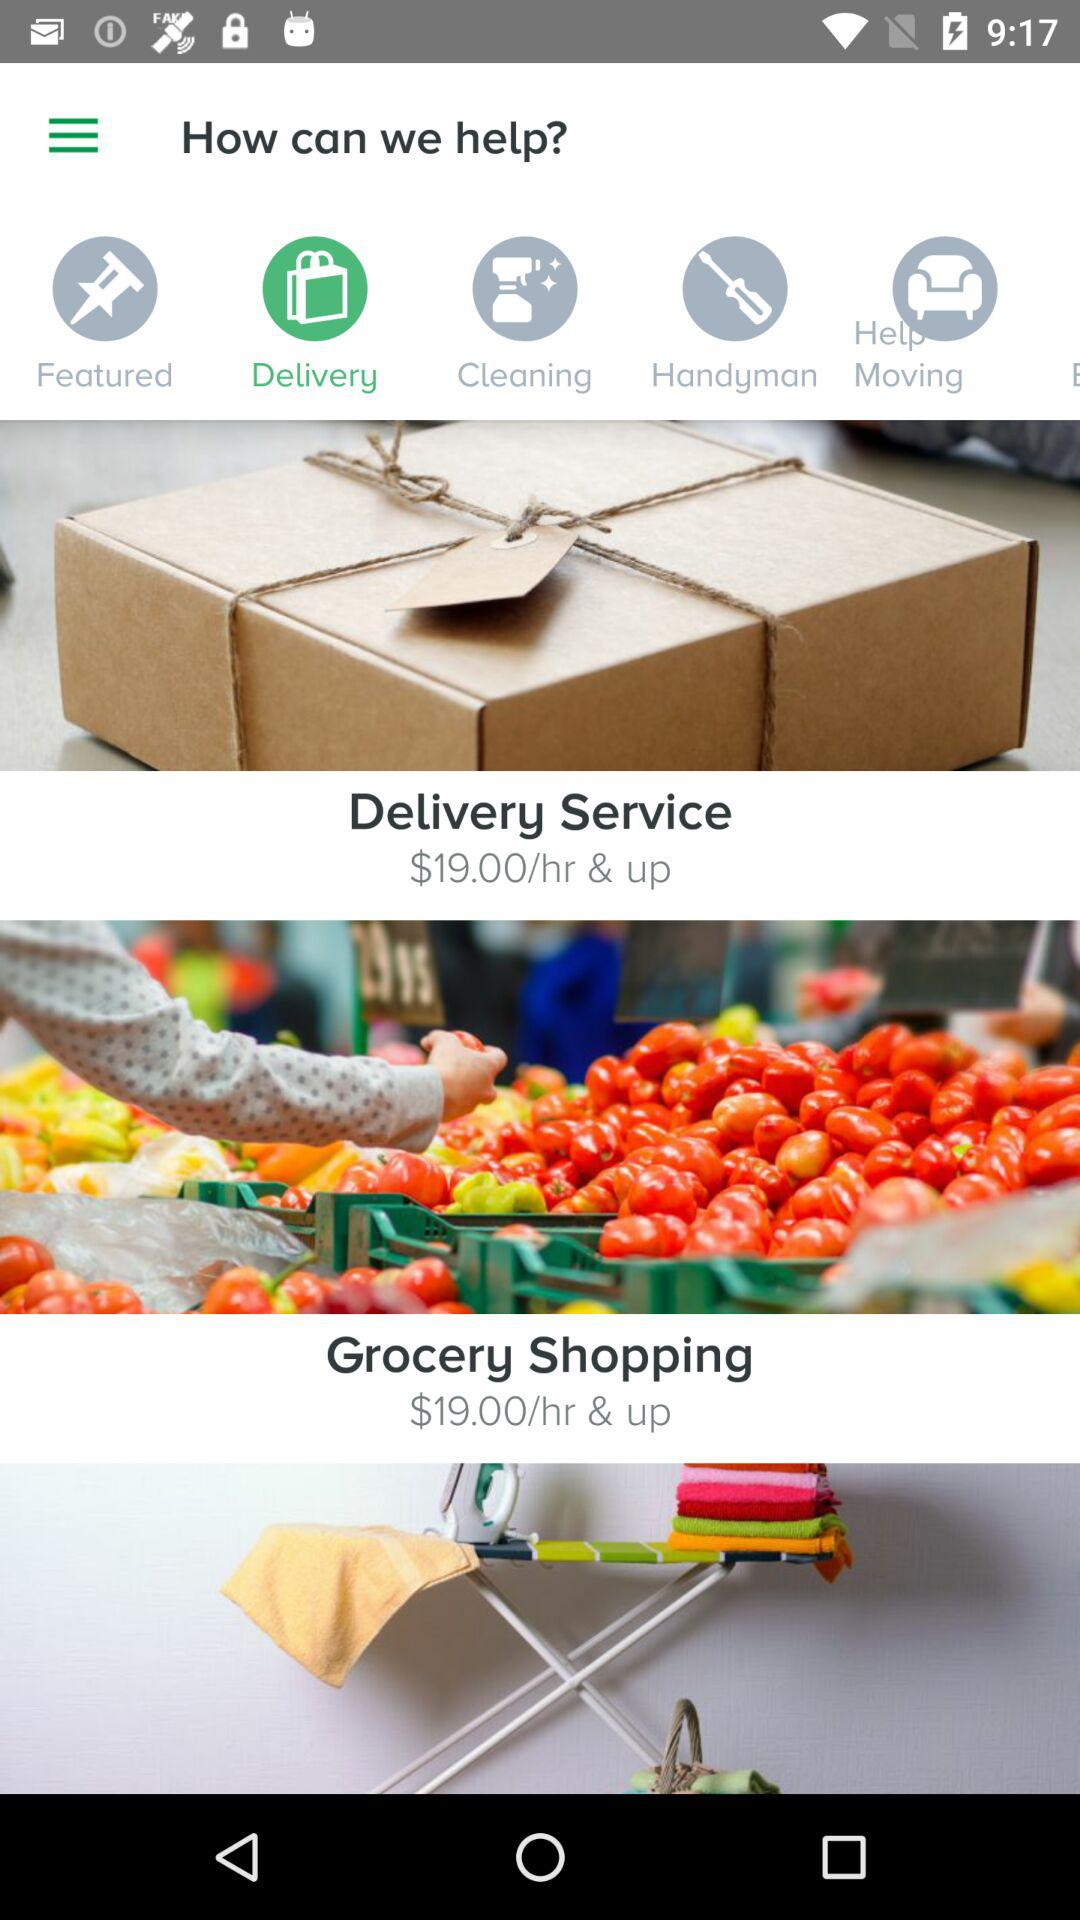What is the price per hour of "Grocery Shopping"? The price per hour of "Grocery Shopping" is $19.00. 